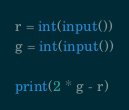Convert code to text. <code><loc_0><loc_0><loc_500><loc_500><_Python_>r = int(input())
g = int(input())

print(2 * g - r)</code> 